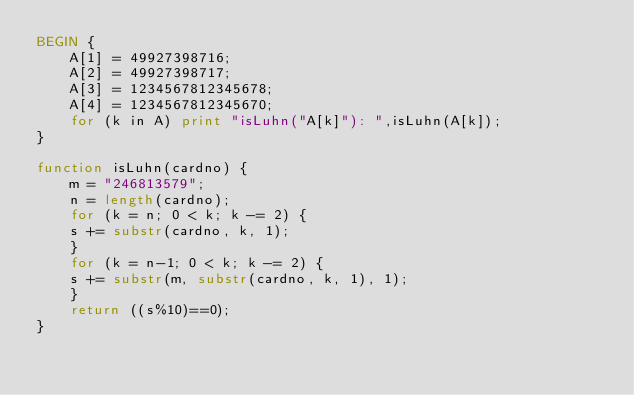<code> <loc_0><loc_0><loc_500><loc_500><_Awk_>BEGIN {
    A[1] = 49927398716;
    A[2] = 49927398717;
    A[3] = 1234567812345678;
    A[4] = 1234567812345670;
    for (k in A) print "isLuhn("A[k]"): ",isLuhn(A[k]);	
}

function isLuhn(cardno) {
    m = "246813579";
    n = length(cardno);
    for (k = n; 0 < k; k -= 2) {
	s += substr(cardno, k, 1);
    }
    for (k = n-1; 0 < k; k -= 2) {
	s += substr(m, substr(cardno, k, 1), 1);
    }
    return ((s%10)==0);	
}
</code> 